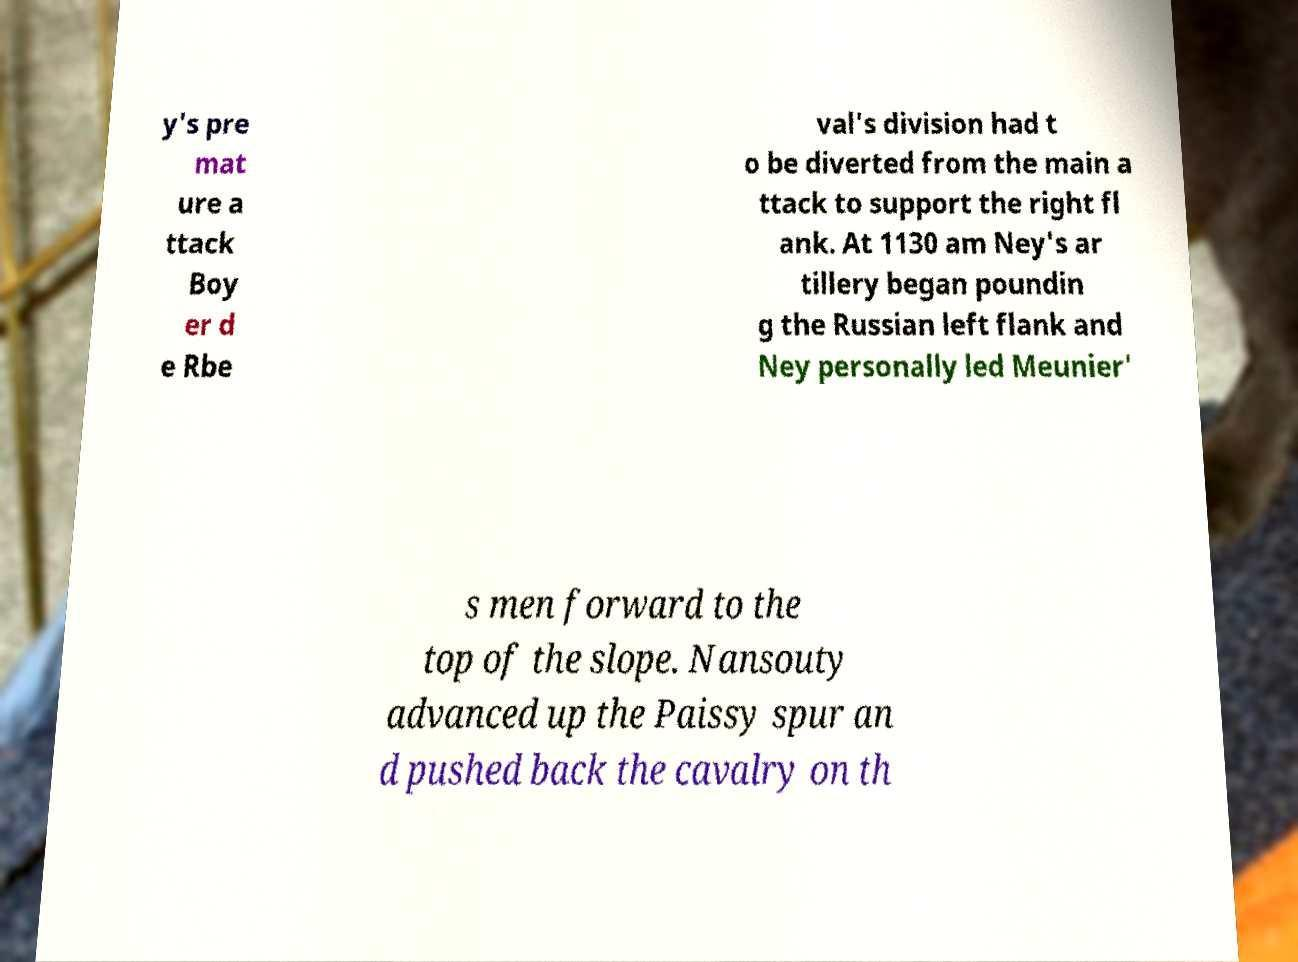I need the written content from this picture converted into text. Can you do that? y's pre mat ure a ttack Boy er d e Rbe val's division had t o be diverted from the main a ttack to support the right fl ank. At 1130 am Ney's ar tillery began poundin g the Russian left flank and Ney personally led Meunier' s men forward to the top of the slope. Nansouty advanced up the Paissy spur an d pushed back the cavalry on th 